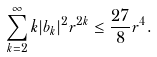Convert formula to latex. <formula><loc_0><loc_0><loc_500><loc_500>\sum _ { k = 2 } ^ { \infty } k | b _ { k } | ^ { 2 } r ^ { 2 k } \leq \frac { 2 7 } { 8 } r ^ { 4 } .</formula> 